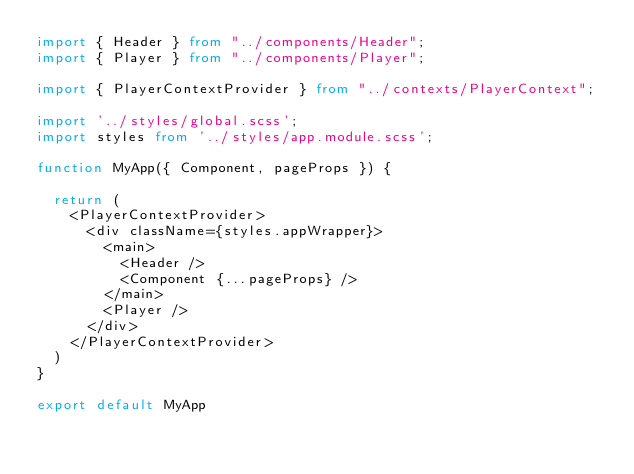<code> <loc_0><loc_0><loc_500><loc_500><_TypeScript_>import { Header } from "../components/Header";
import { Player } from "../components/Player";

import { PlayerContextProvider } from "../contexts/PlayerContext";

import '../styles/global.scss';
import styles from '../styles/app.module.scss';

function MyApp({ Component, pageProps }) {

  return (
    <PlayerContextProvider>
      <div className={styles.appWrapper}>
        <main>
          <Header />
          <Component {...pageProps} />
        </main>
        <Player />
      </div>
    </PlayerContextProvider>
  )
}

export default MyApp
</code> 